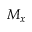Convert formula to latex. <formula><loc_0><loc_0><loc_500><loc_500>M _ { x }</formula> 